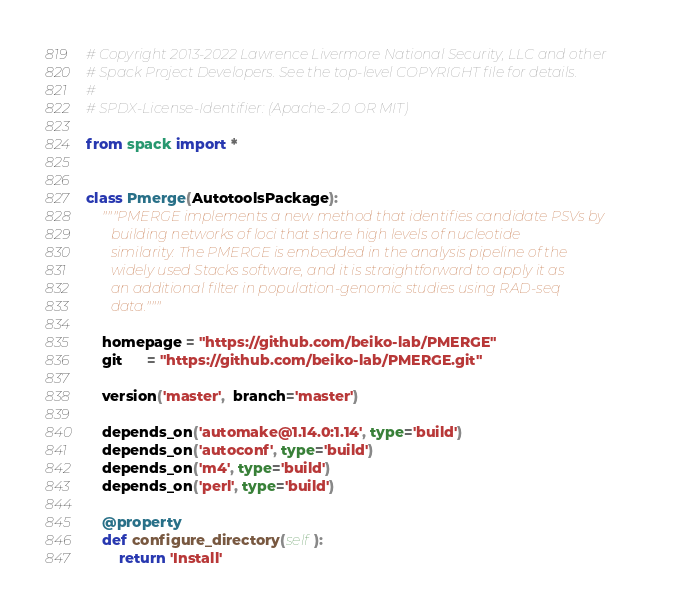<code> <loc_0><loc_0><loc_500><loc_500><_Python_># Copyright 2013-2022 Lawrence Livermore National Security, LLC and other
# Spack Project Developers. See the top-level COPYRIGHT file for details.
#
# SPDX-License-Identifier: (Apache-2.0 OR MIT)

from spack import *


class Pmerge(AutotoolsPackage):
    """PMERGE implements a new method that identifies candidate PSVs by
       building networks of loci that share high levels of nucleotide
       similarity. The PMERGE is embedded in the analysis pipeline of the
       widely used Stacks software, and it is straightforward to apply it as
       an additional filter in population-genomic studies using RAD-seq
       data."""

    homepage = "https://github.com/beiko-lab/PMERGE"
    git      = "https://github.com/beiko-lab/PMERGE.git"

    version('master',  branch='master')

    depends_on('automake@1.14.0:1.14', type='build')
    depends_on('autoconf', type='build')
    depends_on('m4', type='build')
    depends_on('perl', type='build')

    @property
    def configure_directory(self):
        return 'Install'
</code> 